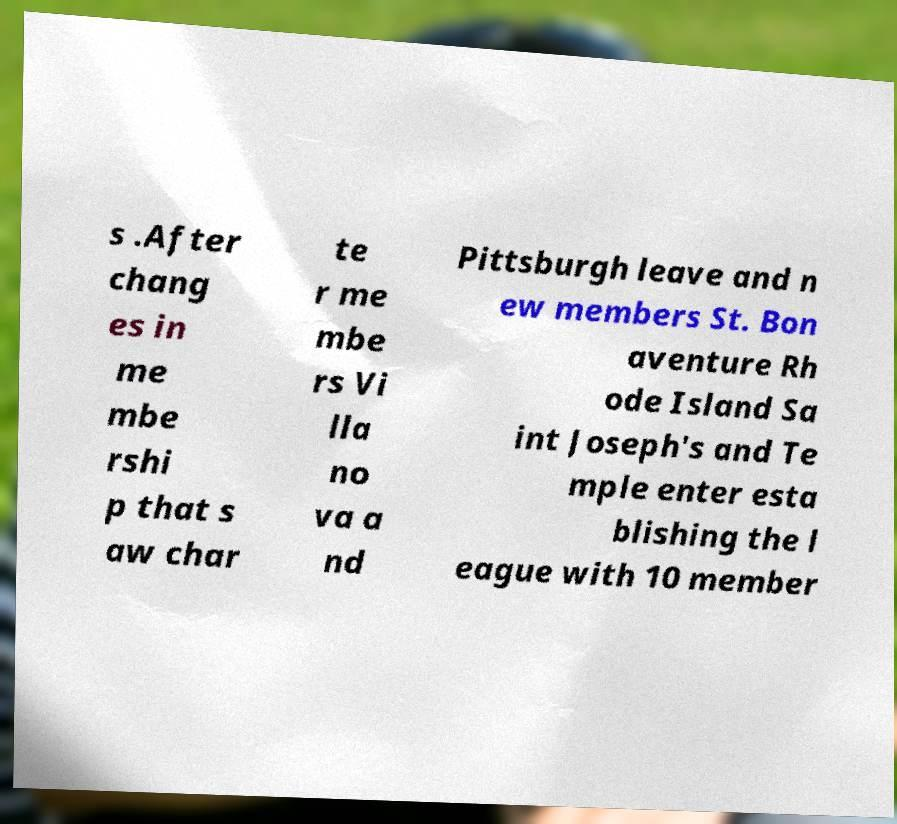Can you accurately transcribe the text from the provided image for me? s .After chang es in me mbe rshi p that s aw char te r me mbe rs Vi lla no va a nd Pittsburgh leave and n ew members St. Bon aventure Rh ode Island Sa int Joseph's and Te mple enter esta blishing the l eague with 10 member 